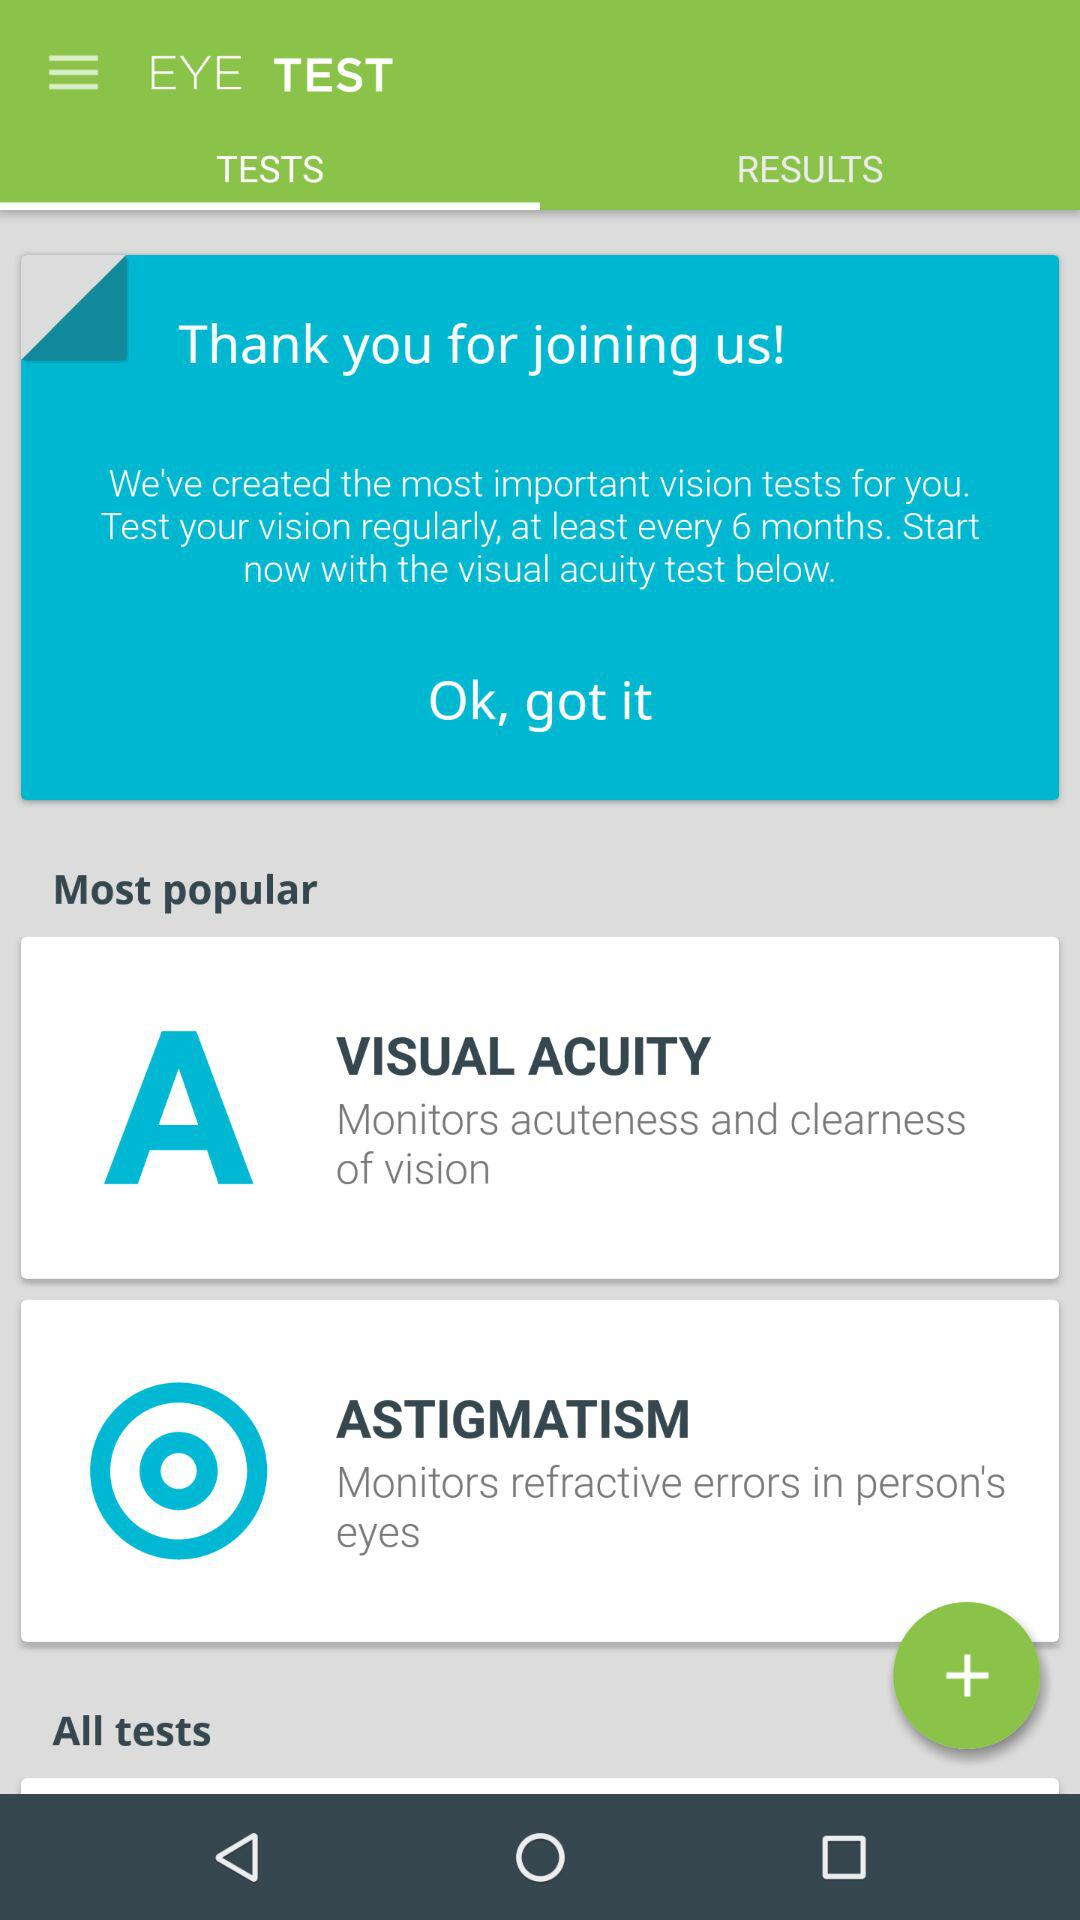Which tab is selected? The selected tab is "TESTS". 